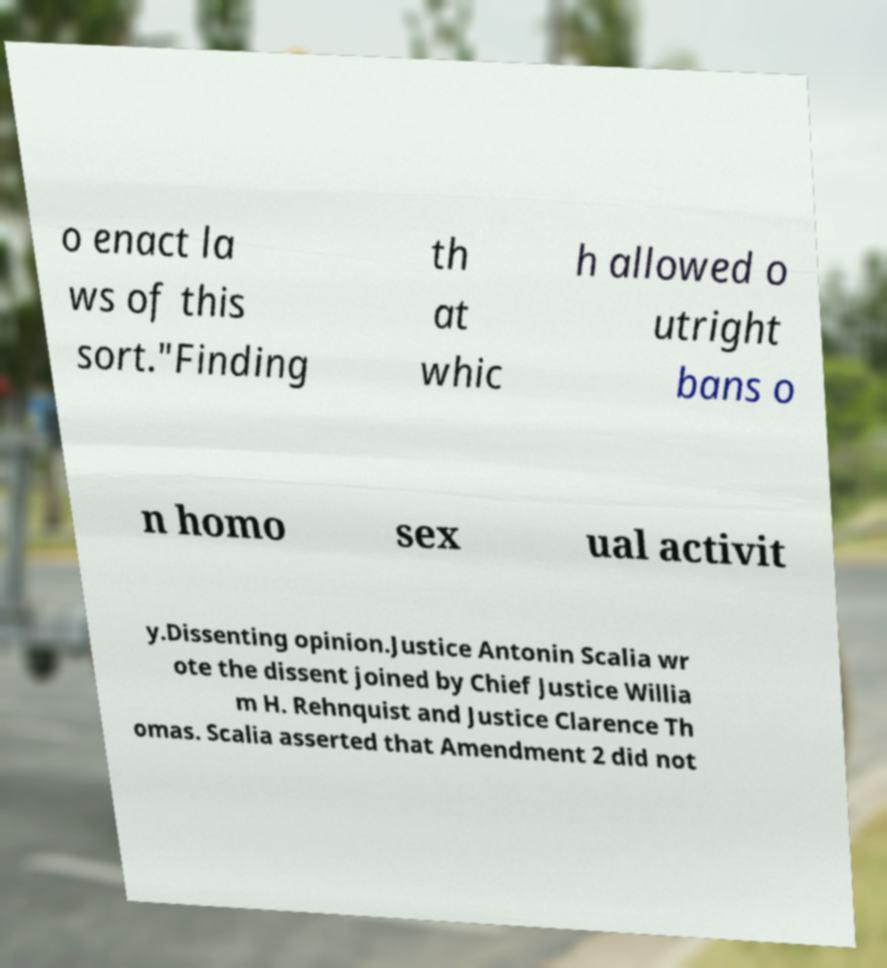Could you extract and type out the text from this image? o enact la ws of this sort."Finding th at whic h allowed o utright bans o n homo sex ual activit y.Dissenting opinion.Justice Antonin Scalia wr ote the dissent joined by Chief Justice Willia m H. Rehnquist and Justice Clarence Th omas. Scalia asserted that Amendment 2 did not 